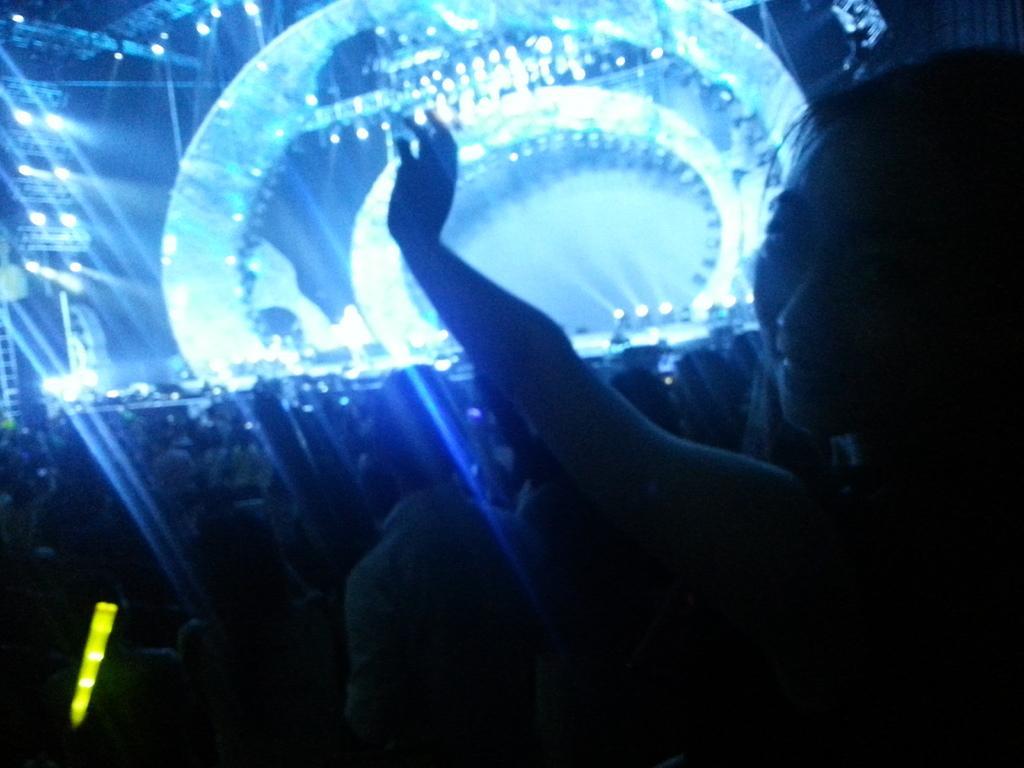In one or two sentences, can you explain what this image depicts? In the foreground of this image, on the right, there is a woman. In the background, there are people, lights on the stage and few poles. 